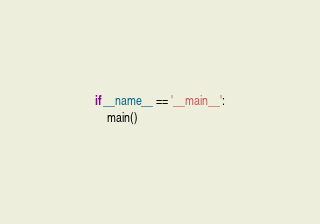Convert code to text. <code><loc_0><loc_0><loc_500><loc_500><_Python_>

if __name__ == '__main__':
    main()
</code> 